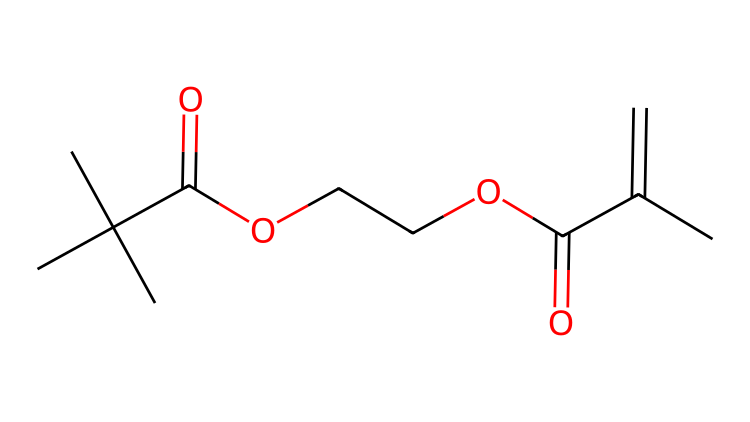What is the total number of carbon atoms in this chemical? By examining the SMILES representation, we count the 'C' characters. There are 12 occurrences of 'C', indicating that there are 12 carbon atoms.
Answer: 12 How many double bonds are present in the structure? The presence of double bonds is indicated by '=' symbols in the SMILES notation. In this case, we see two '=' symbols, indicating there are two double bonds in the chemical structure.
Answer: 2 What is the functional group indicated by 'OCCOC'? 'OCCOC' suggests the presence of an ether functional group, as it has two carbon atoms connected by oxygen atoms. Thus, the presence of ether functionality is confirmed here.
Answer: ether What is the type of the carbon chain found in this chemical? The structure includes branches from the main chain, specifically a tert-butyl group (CC(C)(C)). This indicates the carbon chain is branched.
Answer: branched Identify one key property of this chemical due to its UV-curable nature. The presence of a carbon-carbon double bond (C=C) in the structure makes this chemical suitable for UV-curing processes, which often involve the formation of cross-linking during exposure to UV light.
Answer: cross-linking What type of reaction could this chemical undergo upon UV exposure? The carbon-carbon double bonds (C=C) can undergo a polymerization reaction when exposed to UV light, leading to the formation of a solid material through cross-linking.
Answer: polymerization 